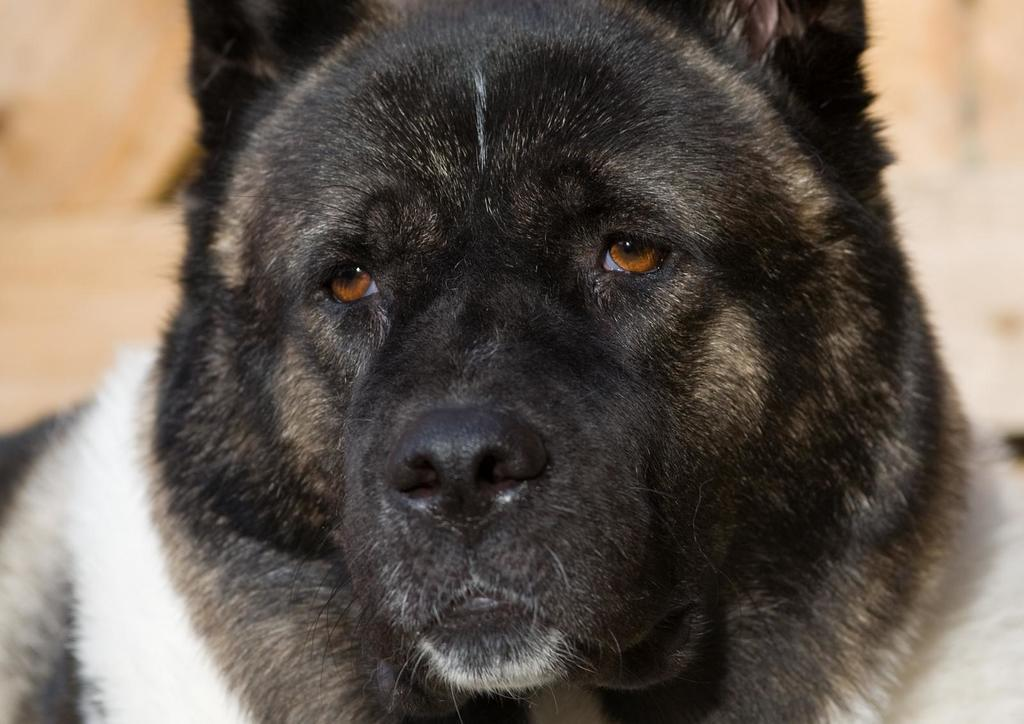What is the main subject in the middle of the image? There is an animal in the middle of the image, which appears to be a dog. How is the dog depicted in the image? The dog is in black and white color. What can be observed about the background of the image? The background of the image is blurred. Where is the writer sitting in the image? There is no writer present in the image; it features a dog in black and white color with a blurred background. 